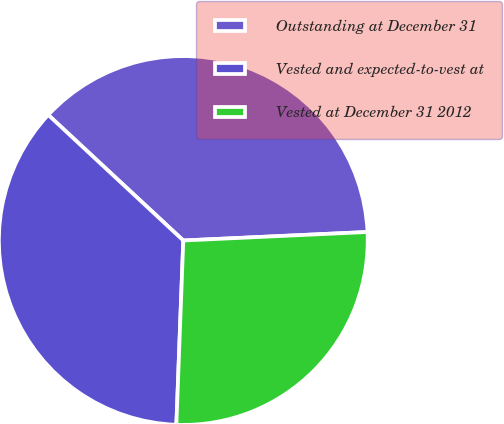Convert chart. <chart><loc_0><loc_0><loc_500><loc_500><pie_chart><fcel>Outstanding at December 31<fcel>Vested and expected-to-vest at<fcel>Vested at December 31 2012<nl><fcel>37.34%<fcel>36.32%<fcel>26.33%<nl></chart> 